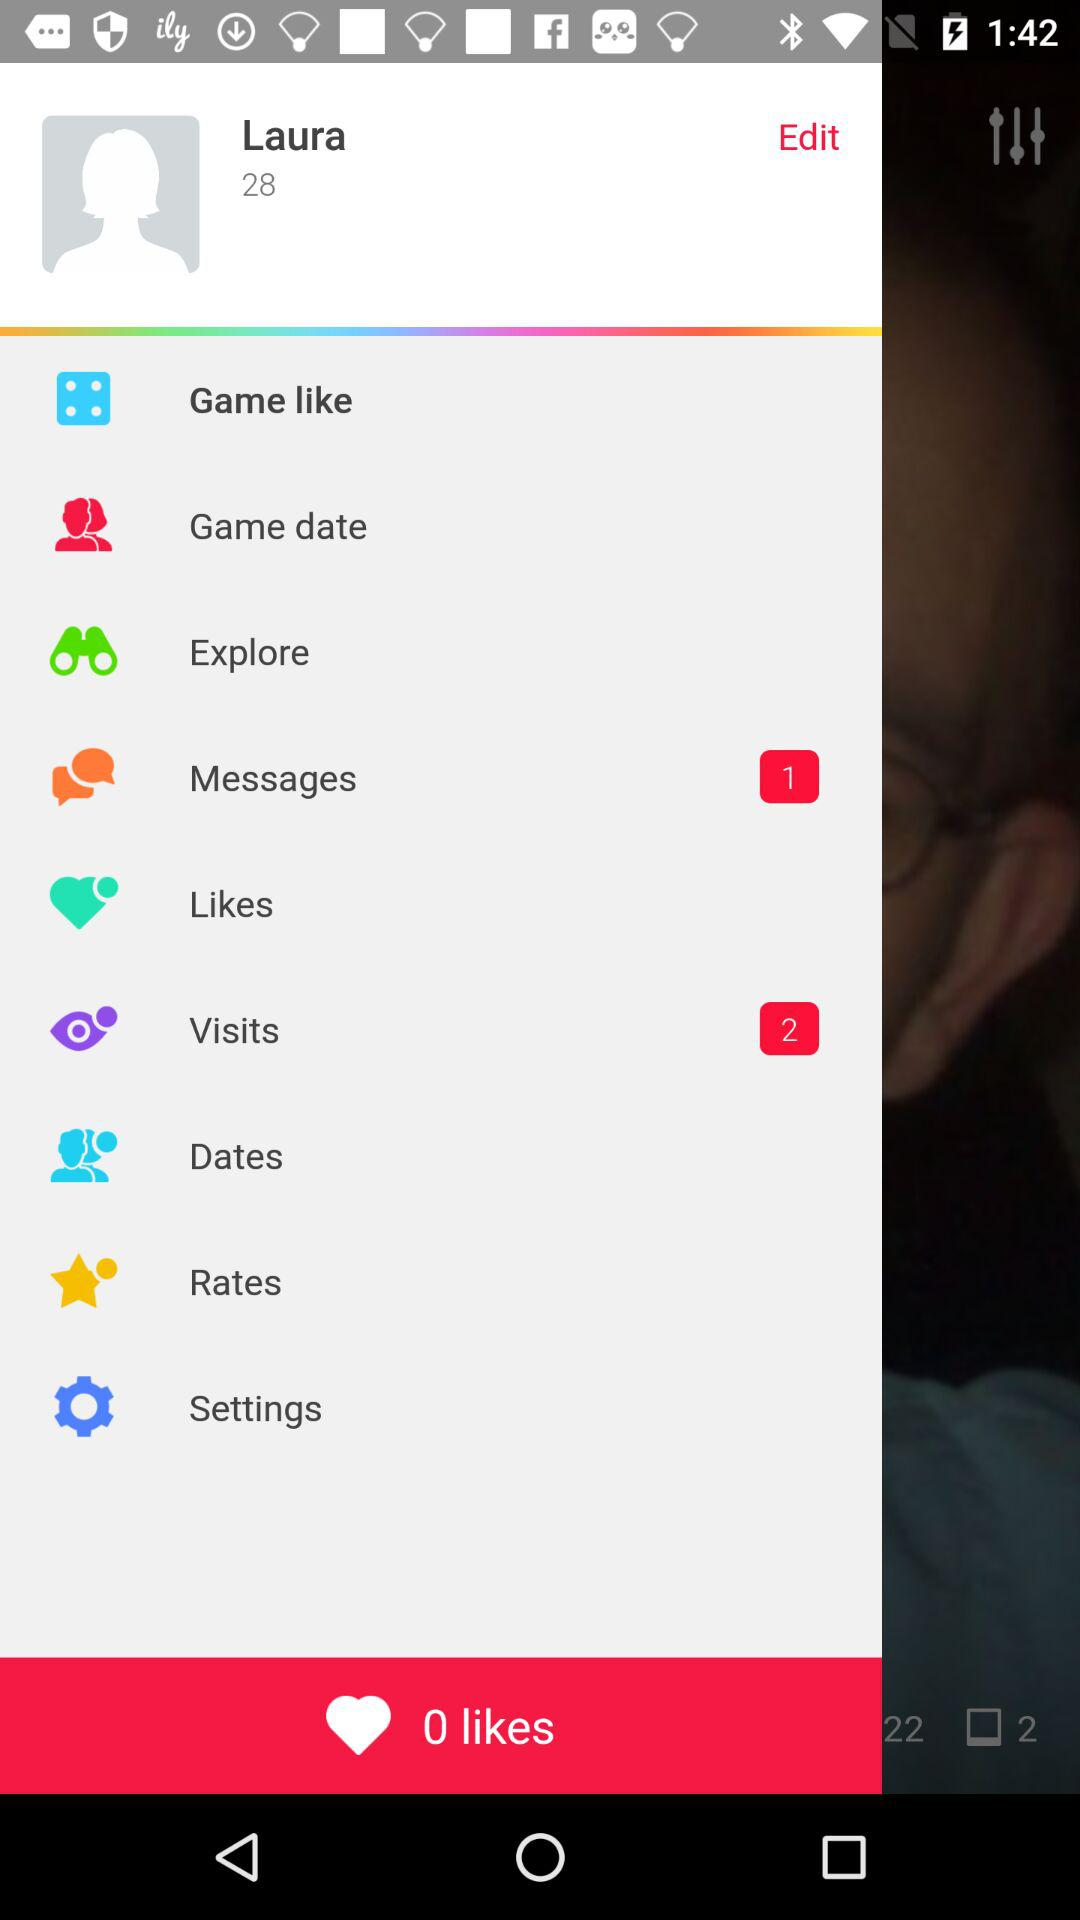How many unread messages are there? There is 1 unread message. 